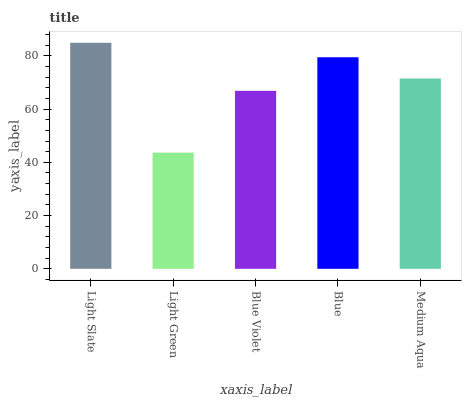Is Blue Violet the minimum?
Answer yes or no. No. Is Blue Violet the maximum?
Answer yes or no. No. Is Blue Violet greater than Light Green?
Answer yes or no. Yes. Is Light Green less than Blue Violet?
Answer yes or no. Yes. Is Light Green greater than Blue Violet?
Answer yes or no. No. Is Blue Violet less than Light Green?
Answer yes or no. No. Is Medium Aqua the high median?
Answer yes or no. Yes. Is Medium Aqua the low median?
Answer yes or no. Yes. Is Light Green the high median?
Answer yes or no. No. Is Blue Violet the low median?
Answer yes or no. No. 